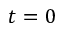Convert formula to latex. <formula><loc_0><loc_0><loc_500><loc_500>t = 0</formula> 